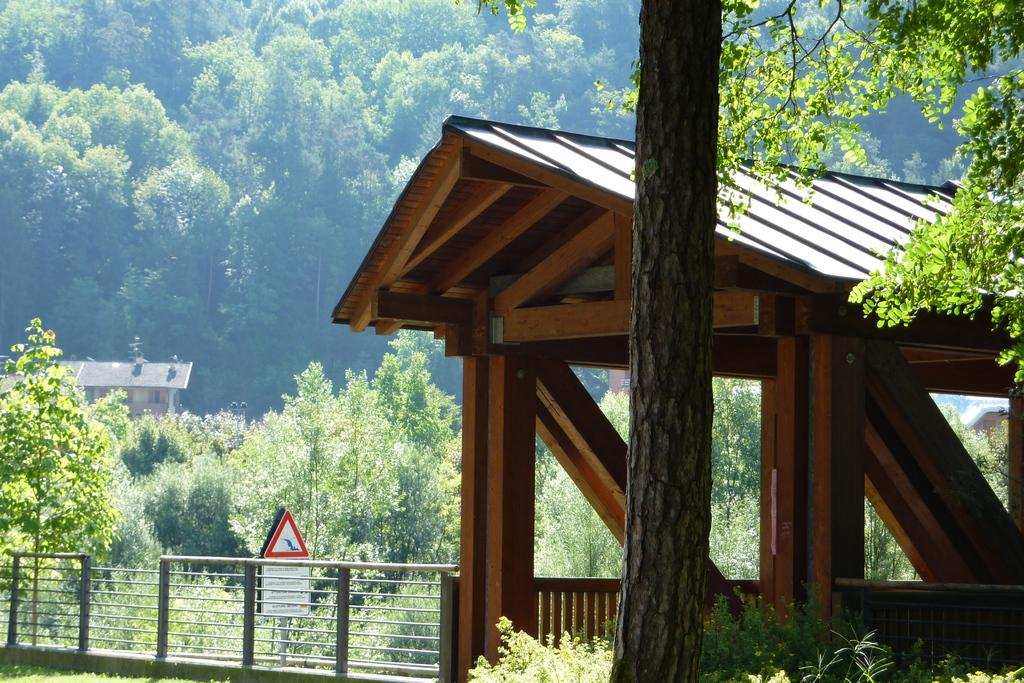What type of structure is present in the image? There is a wooden shed in the image. What natural element can be seen in the image? There is a tree trunk in the image. What type of vegetation is visible in the image? There are trees and plants in the image. What type of barrier is present in the image? There is a fence in the image. What type of signage is present in the image? There is a sign board in the image. What type of residential structures are visible in the image? There are houses in the image. What type of cork can be seen on the tree trunk in the image? There is no cork present on the tree trunk in the image. What type of stone is used to build the houses in the image? The provided facts do not mention the materials used to build the houses in the image. What color is the scarf hanging on the fence in the image? There is no scarf present on the fence in the image. 